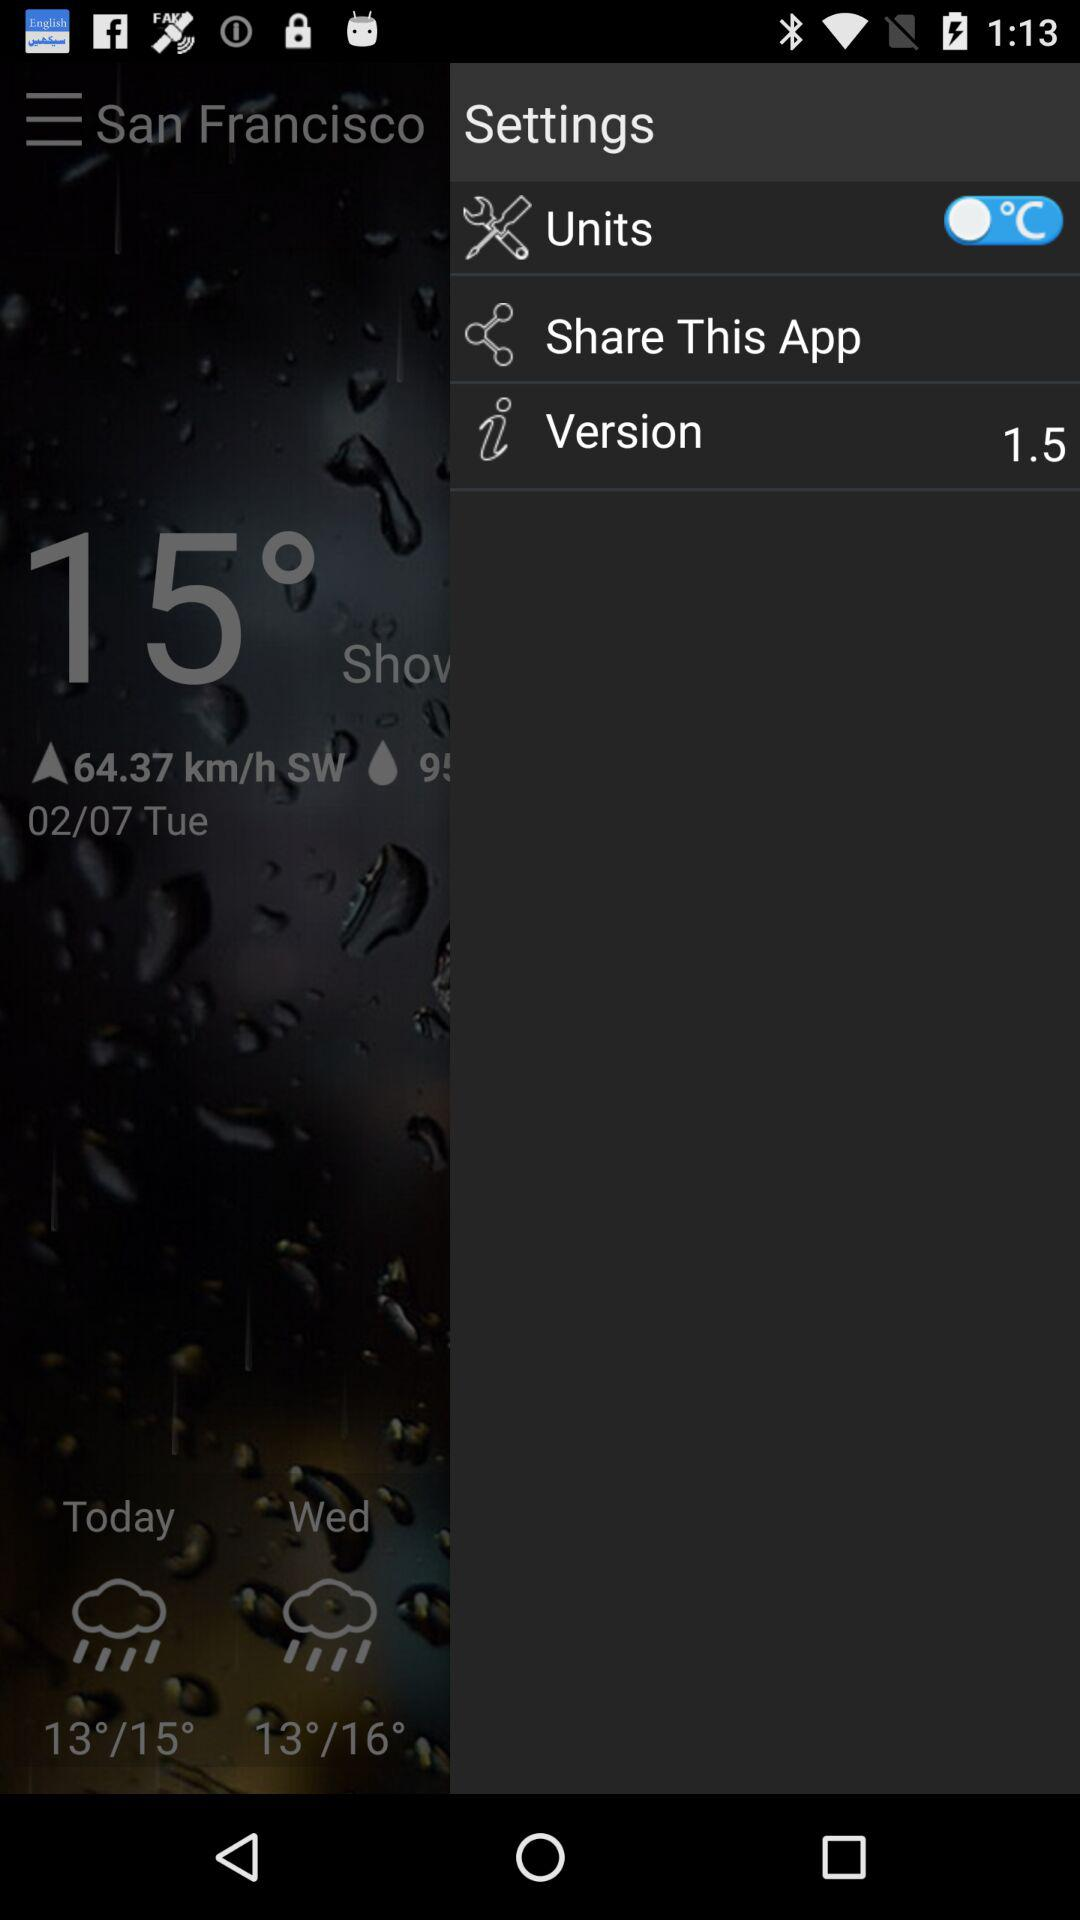What version of the application is this? The version of the application is 1.5. 